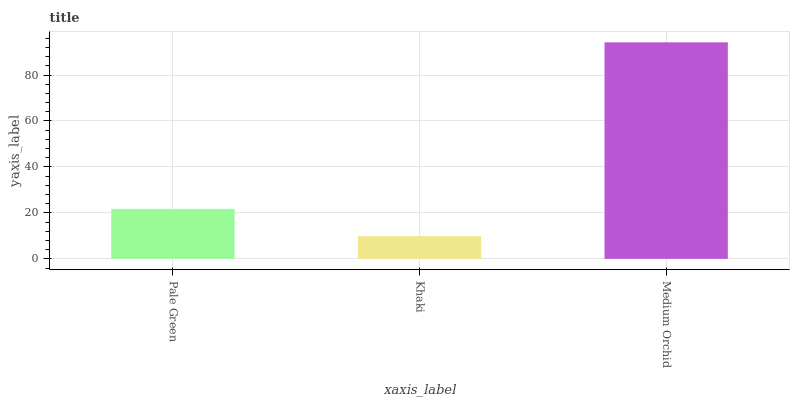Is Khaki the minimum?
Answer yes or no. Yes. Is Medium Orchid the maximum?
Answer yes or no. Yes. Is Medium Orchid the minimum?
Answer yes or no. No. Is Khaki the maximum?
Answer yes or no. No. Is Medium Orchid greater than Khaki?
Answer yes or no. Yes. Is Khaki less than Medium Orchid?
Answer yes or no. Yes. Is Khaki greater than Medium Orchid?
Answer yes or no. No. Is Medium Orchid less than Khaki?
Answer yes or no. No. Is Pale Green the high median?
Answer yes or no. Yes. Is Pale Green the low median?
Answer yes or no. Yes. Is Medium Orchid the high median?
Answer yes or no. No. Is Medium Orchid the low median?
Answer yes or no. No. 